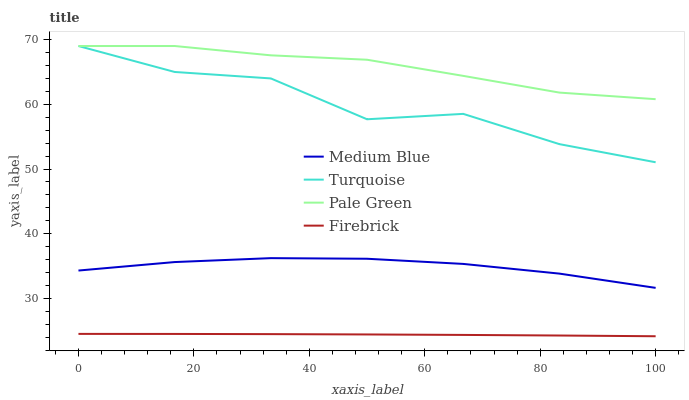Does Firebrick have the minimum area under the curve?
Answer yes or no. Yes. Does Pale Green have the maximum area under the curve?
Answer yes or no. Yes. Does Medium Blue have the minimum area under the curve?
Answer yes or no. No. Does Medium Blue have the maximum area under the curve?
Answer yes or no. No. Is Firebrick the smoothest?
Answer yes or no. Yes. Is Turquoise the roughest?
Answer yes or no. Yes. Is Pale Green the smoothest?
Answer yes or no. No. Is Pale Green the roughest?
Answer yes or no. No. Does Firebrick have the lowest value?
Answer yes or no. Yes. Does Medium Blue have the lowest value?
Answer yes or no. No. Does Pale Green have the highest value?
Answer yes or no. Yes. Does Medium Blue have the highest value?
Answer yes or no. No. Is Medium Blue less than Pale Green?
Answer yes or no. Yes. Is Medium Blue greater than Firebrick?
Answer yes or no. Yes. Does Turquoise intersect Pale Green?
Answer yes or no. Yes. Is Turquoise less than Pale Green?
Answer yes or no. No. Is Turquoise greater than Pale Green?
Answer yes or no. No. Does Medium Blue intersect Pale Green?
Answer yes or no. No. 